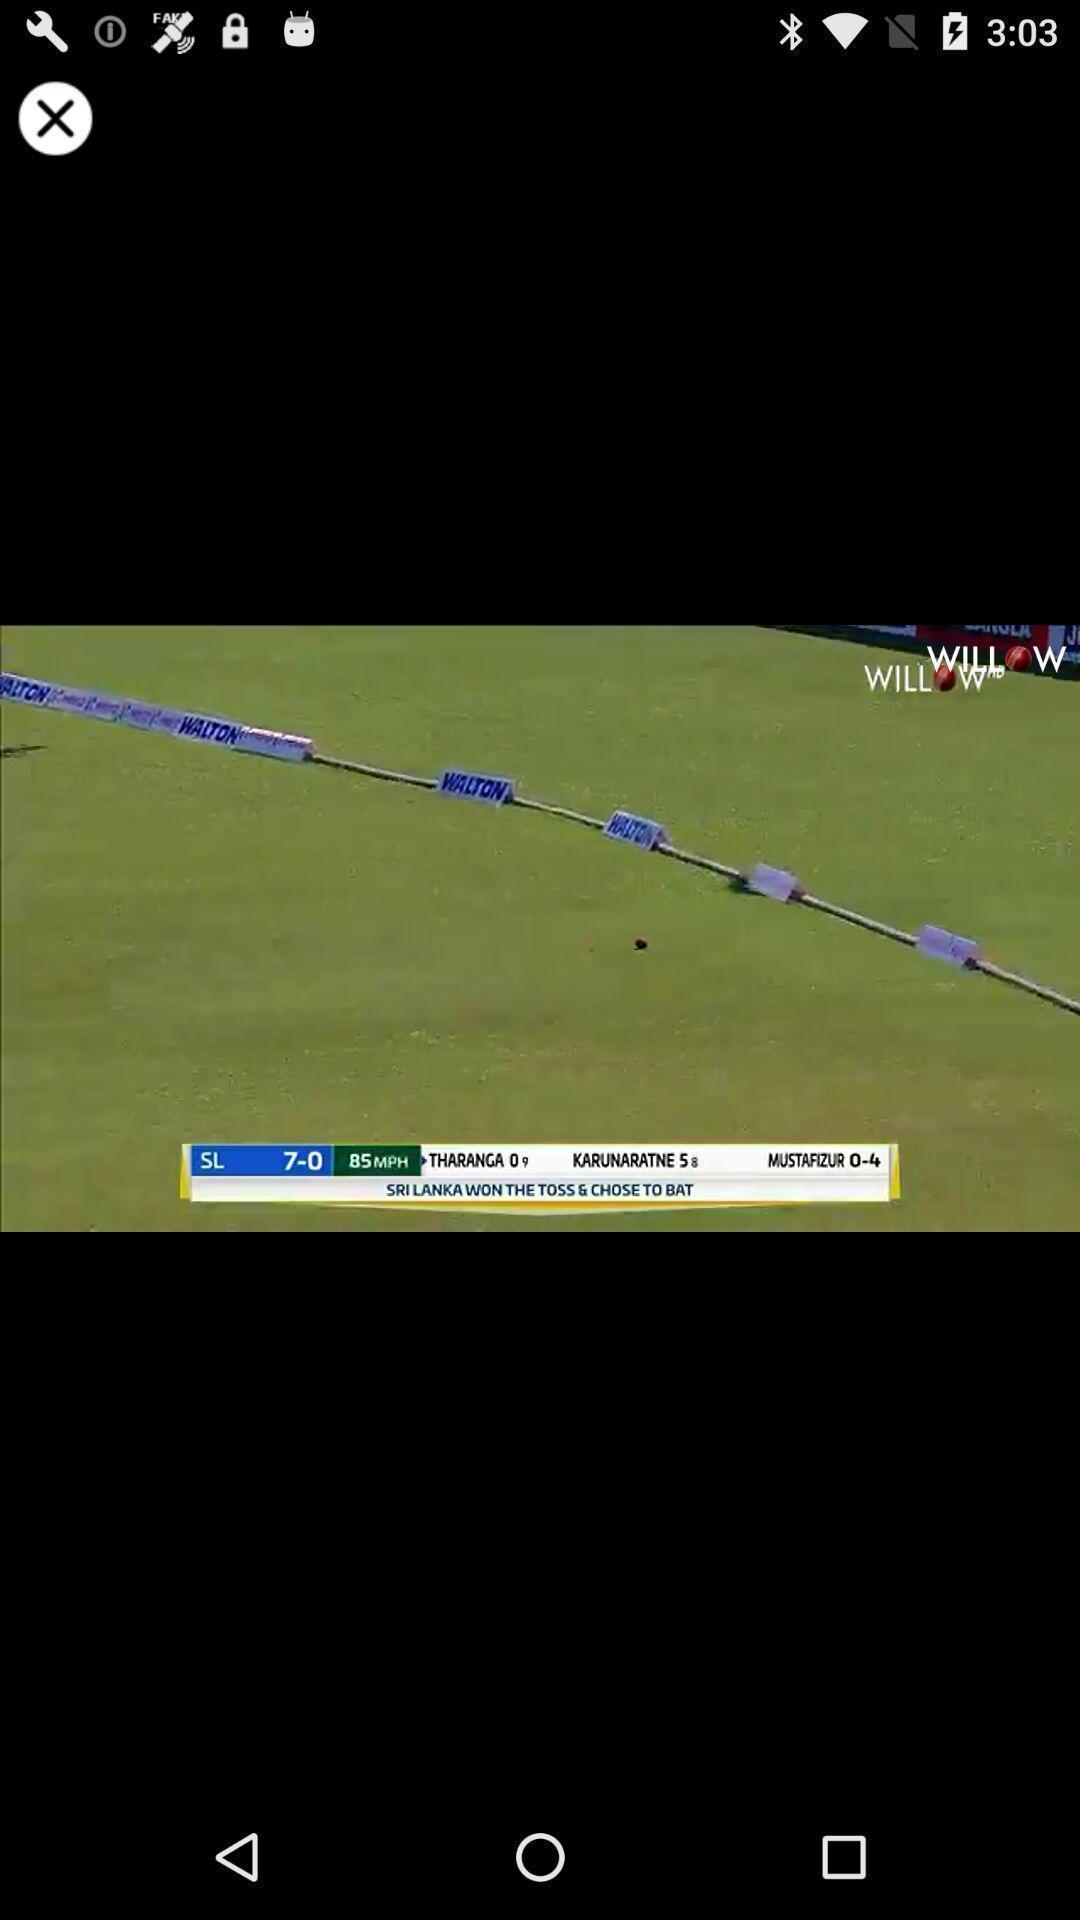Tell me what you see in this picture. Screen shows image with scores in cricket app. 